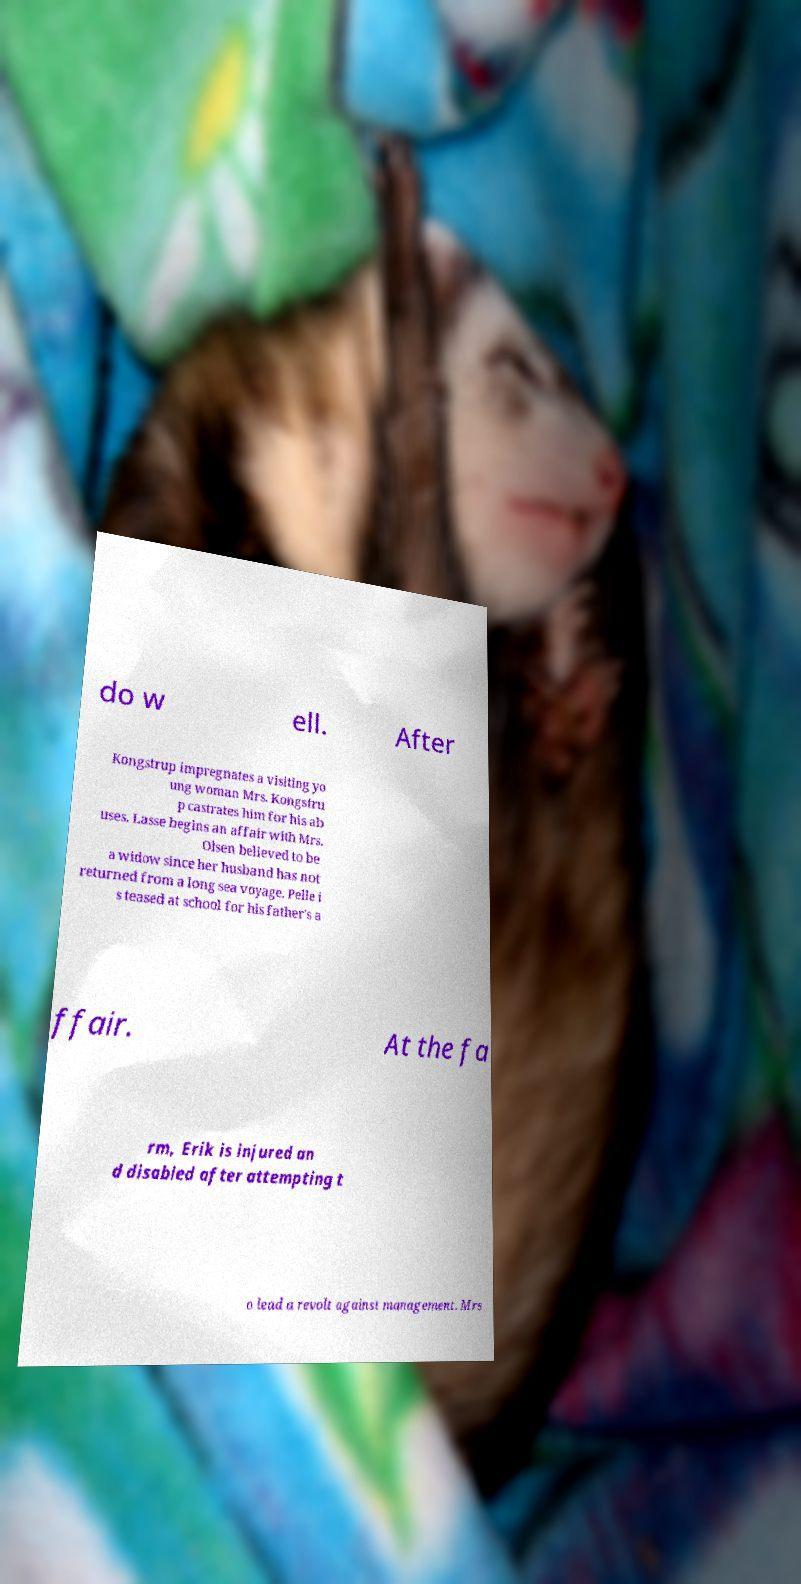For documentation purposes, I need the text within this image transcribed. Could you provide that? do w ell. After Kongstrup impregnates a visiting yo ung woman Mrs. Kongstru p castrates him for his ab uses. Lasse begins an affair with Mrs. Olsen believed to be a widow since her husband has not returned from a long sea voyage. Pelle i s teased at school for his father's a ffair. At the fa rm, Erik is injured an d disabled after attempting t o lead a revolt against management. Mrs 